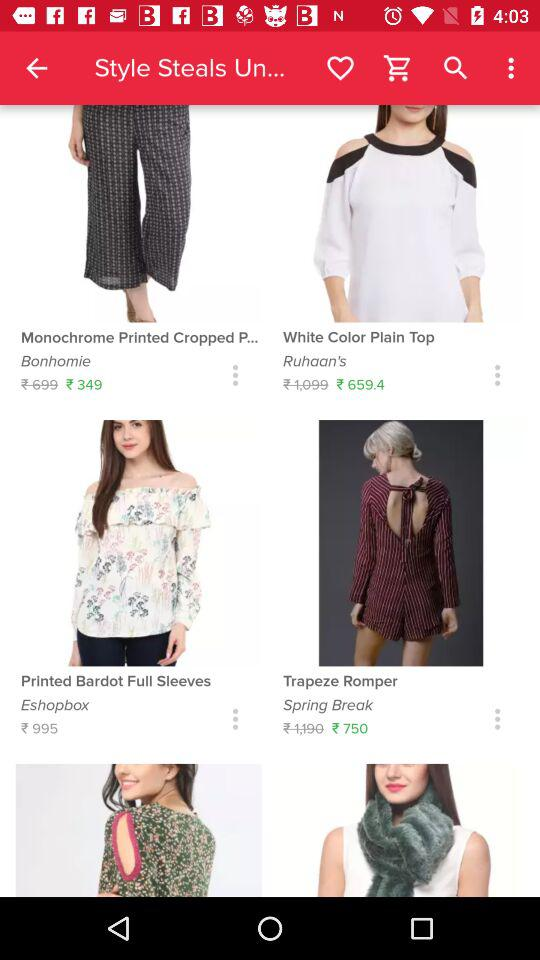What is the price of the "Trapeze Romper"? The price of the "Trapeze Romper" is ₹750. 